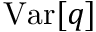<formula> <loc_0><loc_0><loc_500><loc_500>V a r [ q ]</formula> 